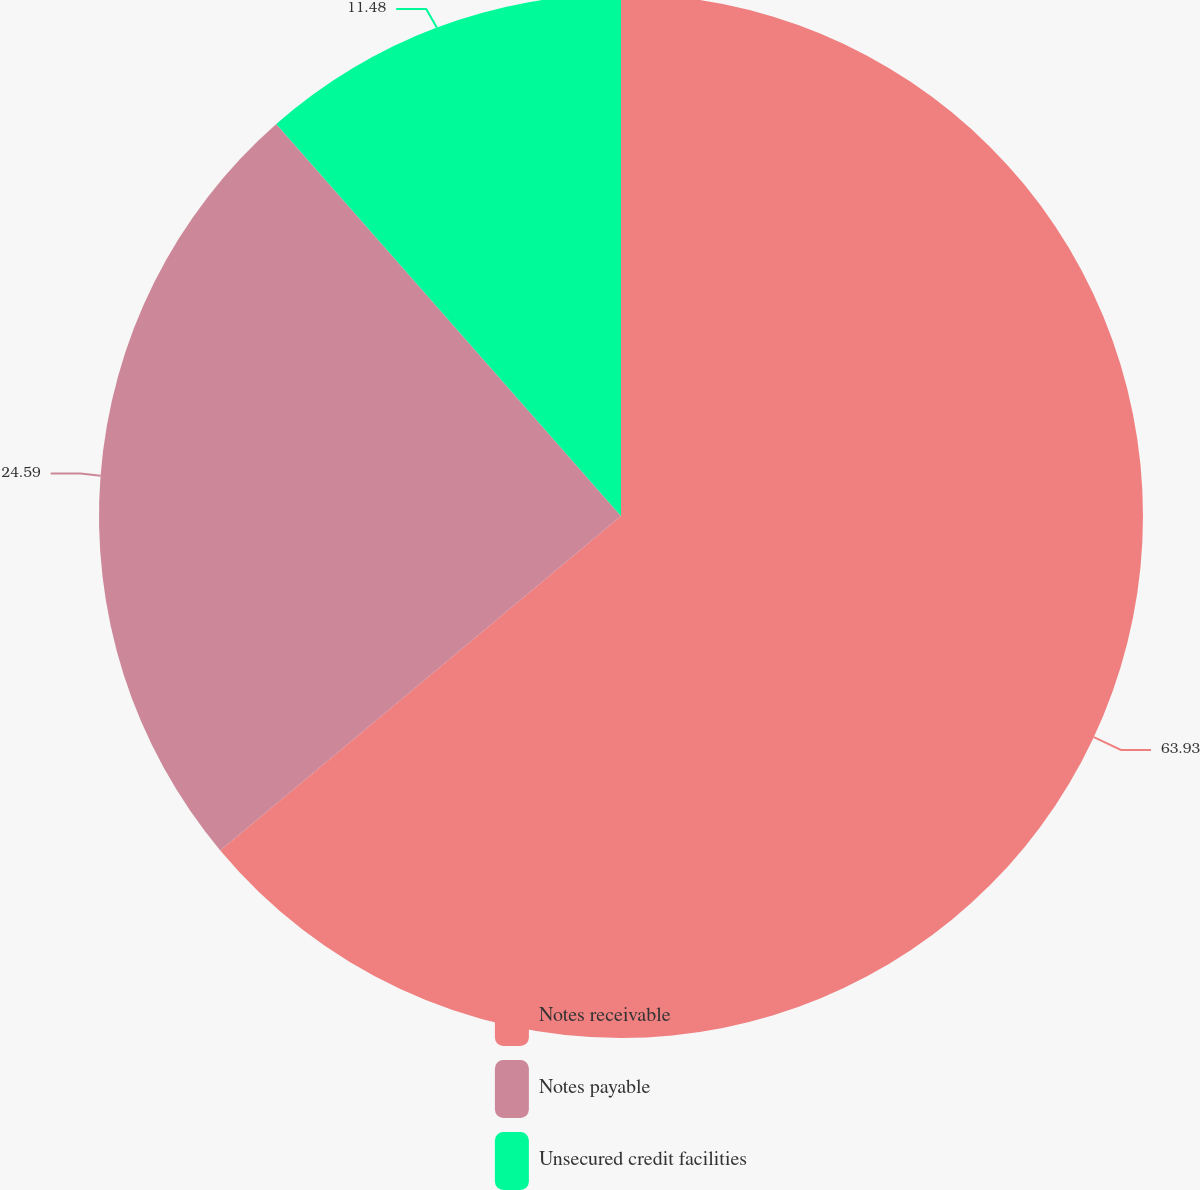<chart> <loc_0><loc_0><loc_500><loc_500><pie_chart><fcel>Notes receivable<fcel>Notes payable<fcel>Unsecured credit facilities<nl><fcel>63.93%<fcel>24.59%<fcel>11.48%<nl></chart> 